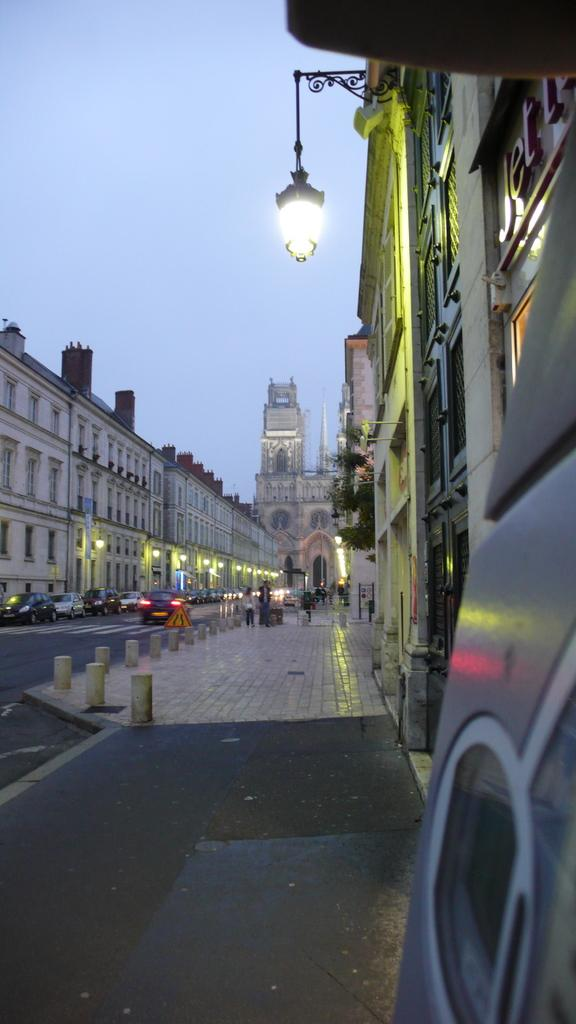What type of structures are visible in the image? There are buildings with windows in the image. What can be seen illuminating the area in the image? There are light poles in the image. What mode of transportation can be seen in the image? There are vehicles in the image. What part of the natural environment is visible in the image? The sky is visible in the image. What are the people in the image doing? There are people standing on the road in the image. Which direction is the rifle pointing in the image? There is no rifle present in the image. What type of plant is growing near the light poles in the image? The provided facts do not mention any plants or stems in the image. 